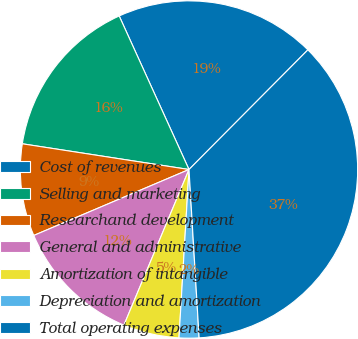<chart> <loc_0><loc_0><loc_500><loc_500><pie_chart><fcel>Cost of revenues<fcel>Selling and marketing<fcel>Researchand development<fcel>General and administrative<fcel>Amortization of intangible<fcel>Depreciation and amortization<fcel>Total operating expenses<nl><fcel>19.24%<fcel>15.77%<fcel>8.83%<fcel>12.3%<fcel>5.36%<fcel>1.9%<fcel>36.59%<nl></chart> 